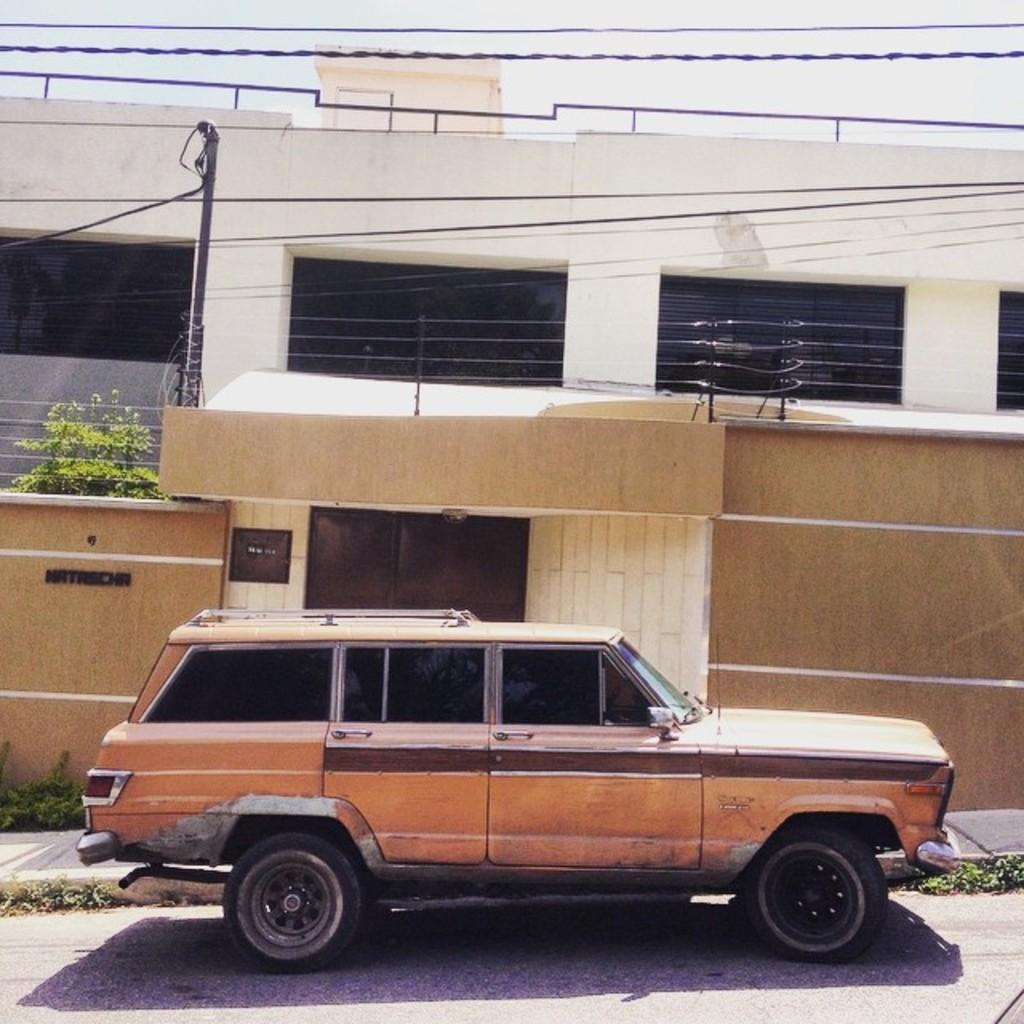What is the main subject of the image? The main subject of the image is a car. Can you describe the car in the image? The car is brown in color. Where is the car located in the image? The car is parked on the road. What can be seen in the background of the image? In the background of the image, there is a wall, wires, a pole, trees, and a house. How many men are visible in the image? There are no men visible in the image; it only features a car and elements in the background. Is there a prison visible in the image? There is no prison present in the image. 